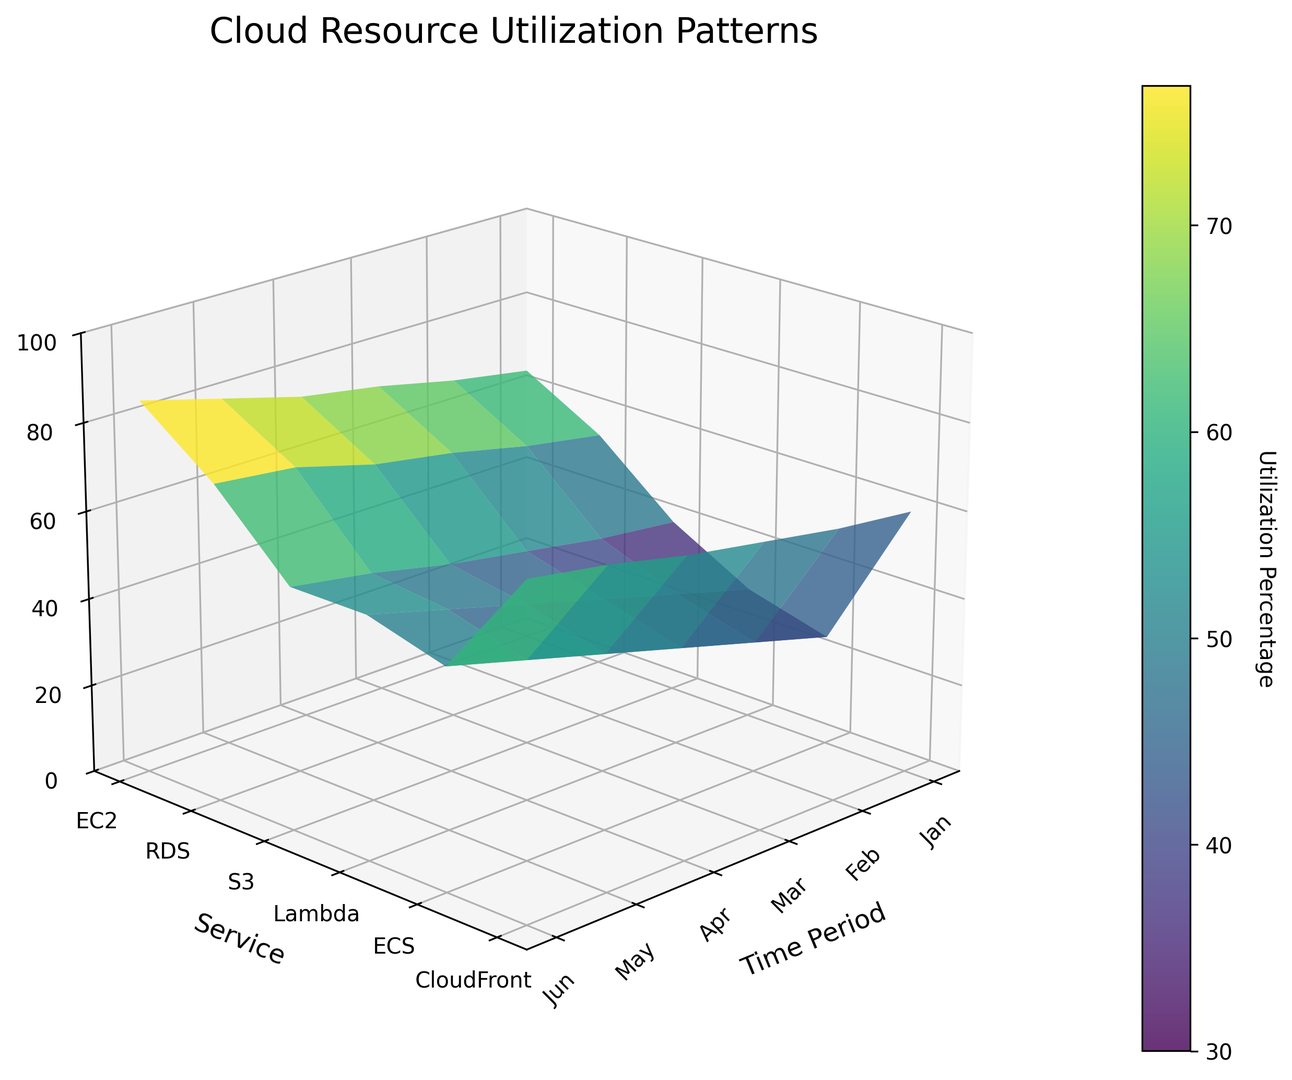What is the average utilization percentage for EC2 in the first half of the year? First, identify the utilization percentages for EC2 from January to June (65, 68, 72, 75, 80, 85). Sum these values (65 + 68 + 72 + 75 + 80 + 85 = 445) and then divide by the number of months (6). So, the average is 445/6 ≈ 74.17
Answer: 74.17 In which month does Lambda exceed ECS in utilization for the first time? Track the utilization percentages for Lambda and ECS month by month. Lambda is first above ECS in February. Lambda is 35, and ECS is 30.
Answer: February Which service shows the highest utilization percentage in June? Look at the utilization percentages for all services in June: EC2 (85), RDS (72), S3 (55), Lambda (55), ECS (50), CloudFront (75). EC2 has the highest utilization.
Answer: EC2 Compare the utilization trends of CloudFront and S3 throughout the first half of the year. Which service shows a steeper increase? Calculate the difference between January and June for both services: CloudFront (75 - 60 = 15) and S3 (55 - 40 = 15). Both services show an equal increase of 15.
Answer: Equal increase What is the combined utilization percentage for S3 and Lambda in March? Identify the March utilization percentages for S3 (45) and Lambda (40). Sum these values (45 + 40). The combined utilization is 85.
Answer: 85 Which month shows the highest utilization for RDS? Look at the utilization percentages for RDS across all months. June has the highest value at 72.
Answer: June Compare the utilization percentage of EC2 in January and Lambda in June. Which one is higher? EC2 in January has a utilization of 65. Lambda in June has a utilization of 55. EC2 in January is higher.
Answer: EC2 in January Is there any service that has a consistent increase in utilization every month? Check each service's monthly utilization: EC2 (65, 68, 72, 75, 80, 85), RDS (55, 58, 62, 65, 70, 72), S3 (40, 42, 45, 48, 52, 55), Lambda (30, 35, 40, 45, 50, 55), ECS (25, 30, 35, 40, 45, 50), CloudFront (60, 62, 65, 68, 72, 75). All services show a consistent increase every month.
Answer: All services 